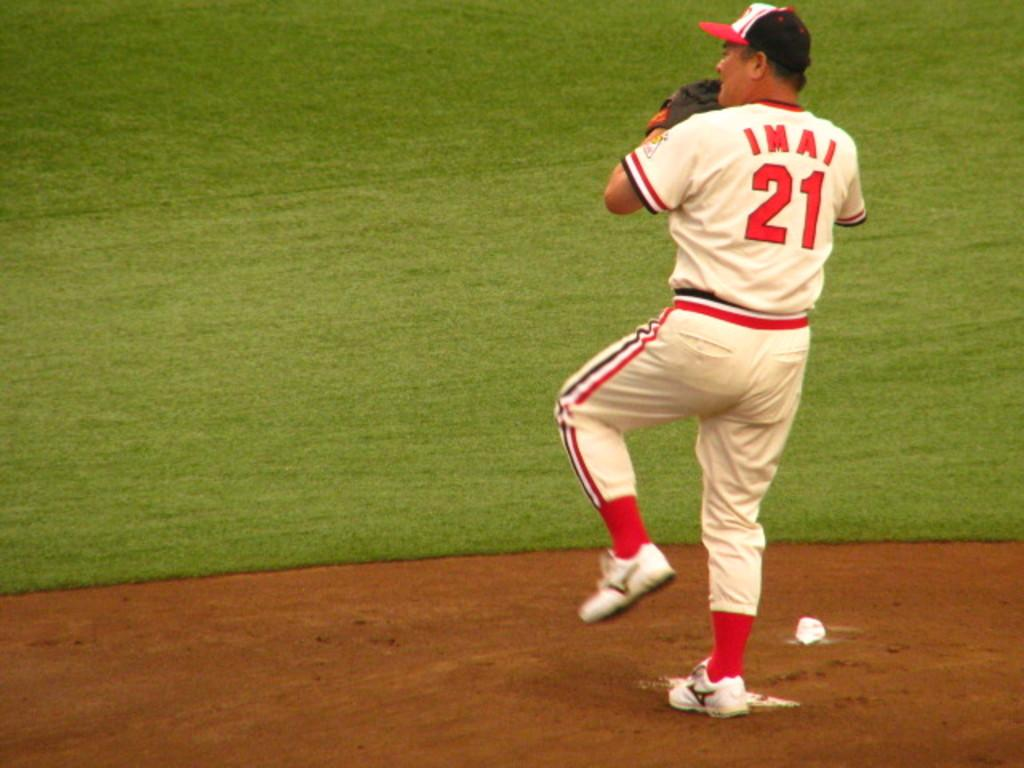<image>
Create a compact narrative representing the image presented. Imai, number 21, prepares to pitch the ball in a game of baseball. 